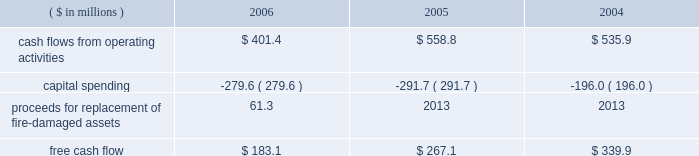Page 29 of 98 in connection with the internal revenue service 2019s ( irs ) examination of ball 2019s consolidated income tax returns for the tax years 2000 through 2004 , the irs has proposed to disallow ball 2019s deductions of interest expense incurred on loans under a company-owned life insurance plan that has been in place for more than 20 years .
Ball believes that its interest deductions will be sustained as filed and , therefore , no provision for loss has been recorded .
The total potential liability for the audit years 1999 through 2004 , unaudited year 2005 and an estimate of the impact on 2006 is approximately $ 31 million , excluding related interest .
The irs has withdrawn its proposed adjustments for any penalties .
See note 13 accompanying the consolidated financial statements within item 8 of this annual report .
Results of equity affiliates equity in the earnings of affiliates in 2006 is primarily attributable to our 50 percent ownership in packaging investments in the u.s .
And brazil .
Earnings in 2004 included the results of a minority-owned aerospace business , which was sold in october 2005 , and a $ 15.2 million loss representing ball 2019s share of a provision for doubtful accounts relating to its 35 percent interest in sanshui jfp ( discussed above in 201cmetal beverage packaging , europe/asia 201d ) .
After consideration of the prc loss , earnings were $ 14.7 million in 2006 compared to $ 15.5 million in 2005 and $ 15.8 million in 2004 .
Critical and significant accounting policies and new accounting pronouncements for information regarding the company 2019s critical and significant accounting policies , as well as recent accounting pronouncements , see note 1 to the consolidated financial statements within item 8 of this report .
Financial condition , liquidity and capital resources cash flows and capital expenditures cash flows from operating activities were $ 401.4 million in 2006 compared to $ 558.8 million in 2005 and $ 535.9 million in 2004 .
Management internally uses a free cash flow measure : ( 1 ) to evaluate the company 2019s operating results , ( 2 ) for planning purposes , ( 3 ) to evaluate strategic investments and ( 4 ) to evaluate the company 2019s ability to incur and service debt .
Free cash flow is not a defined term under u.s .
Generally accepted accounting principles , and it should not be inferred that the entire free cash flow amount is available for discretionary expenditures .
The company defines free cash flow as cash flow from operating activities less additions to property , plant and equipment ( capital spending ) .
Free cash flow is typically derived directly from the company 2019s cash flow statements ; however , it may be adjusted for items that affect comparability between periods .
An example of such an item included in 2006 is the property insurance proceeds for the replacement of the fire-damaged assets in our hassloch , germany , plant , which is included in capital spending amounts .
Based on this , our consolidated free cash flow is summarized as follows: .
Cash flows from operating activities in 2006 were negatively affected by higher cash pension funding and higher working capital levels compared to the prior year .
The higher working capital was a combination of higher than planned raw material inventory levels , higher income tax payments and higher accounts receivable balances , the latter resulting primarily from the repayment of a portion of the accounts receivable securitization program and late payments from customers in europe .
Management expects the increase in working capital to be temporary and that working capital levels will return to normal levels by the end of the first half of 2007. .
Did cash flows from operating activities increase in 2006 compared to 2005? 
Computations: (401.4 > 558.8)
Answer: no. 